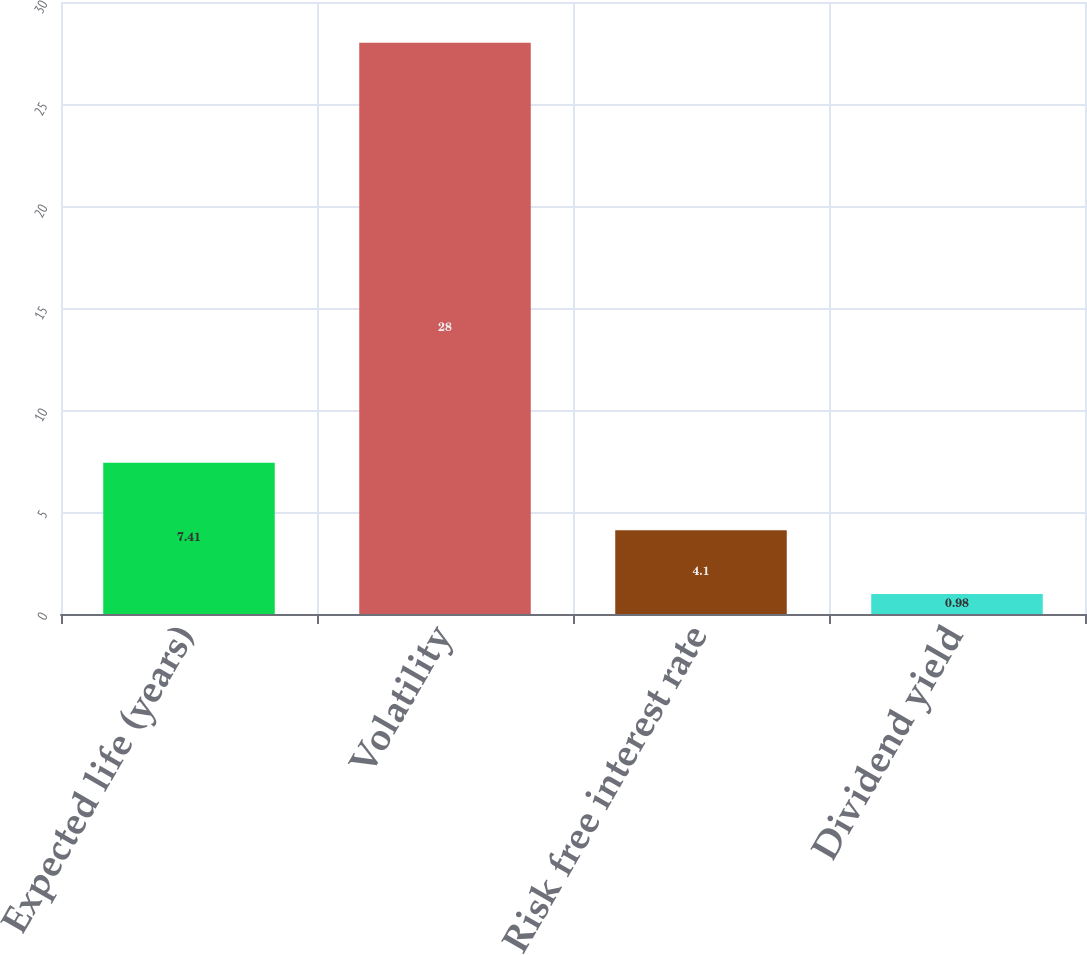<chart> <loc_0><loc_0><loc_500><loc_500><bar_chart><fcel>Expected life (years)<fcel>Volatility<fcel>Risk free interest rate<fcel>Dividend yield<nl><fcel>7.41<fcel>28<fcel>4.1<fcel>0.98<nl></chart> 